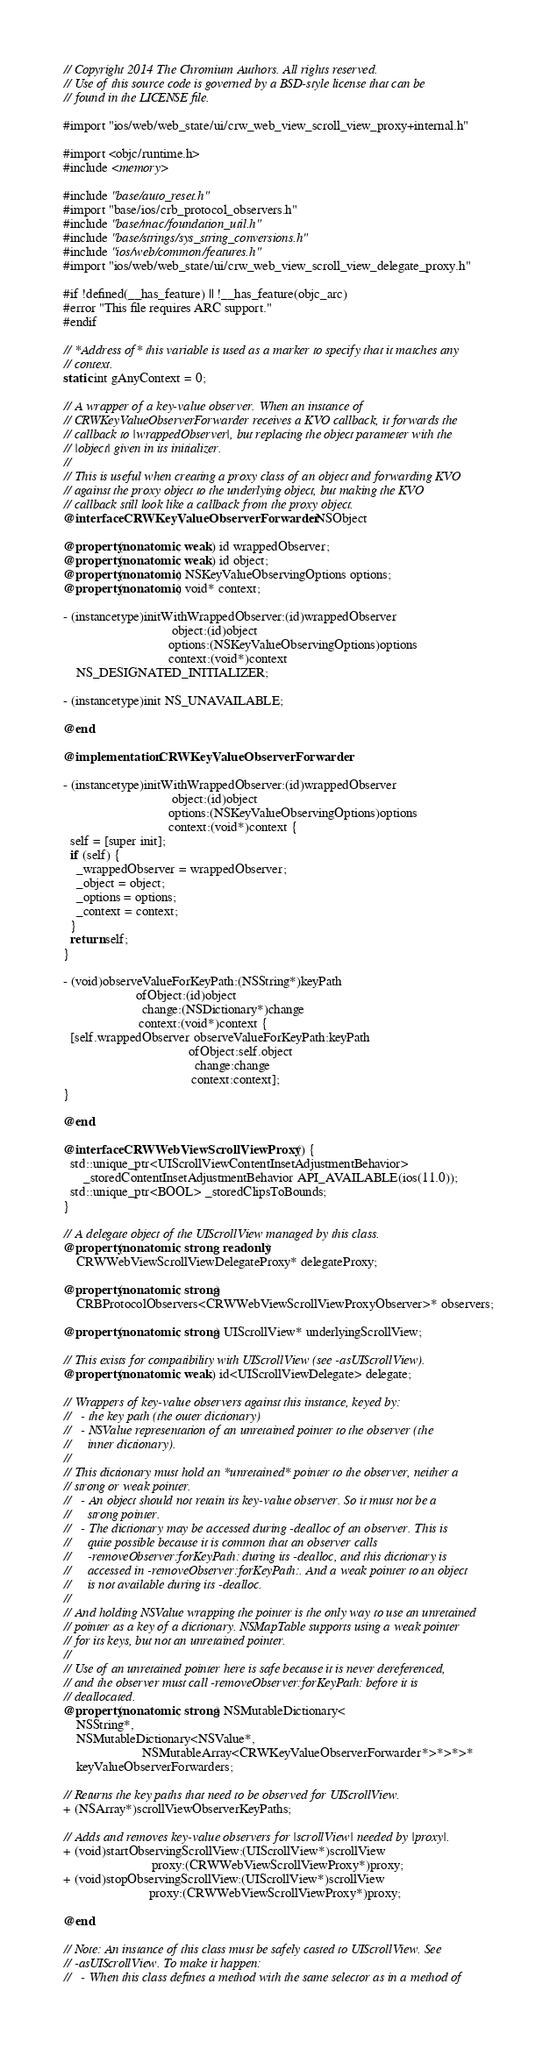<code> <loc_0><loc_0><loc_500><loc_500><_ObjectiveC_>// Copyright 2014 The Chromium Authors. All rights reserved.
// Use of this source code is governed by a BSD-style license that can be
// found in the LICENSE file.

#import "ios/web/web_state/ui/crw_web_view_scroll_view_proxy+internal.h"

#import <objc/runtime.h>
#include <memory>

#include "base/auto_reset.h"
#import "base/ios/crb_protocol_observers.h"
#include "base/mac/foundation_util.h"
#include "base/strings/sys_string_conversions.h"
#include "ios/web/common/features.h"
#import "ios/web/web_state/ui/crw_web_view_scroll_view_delegate_proxy.h"

#if !defined(__has_feature) || !__has_feature(objc_arc)
#error "This file requires ARC support."
#endif

// *Address of* this variable is used as a marker to specify that it matches any
// context.
static int gAnyContext = 0;

// A wrapper of a key-value observer. When an instance of
// CRWKeyValueObserverForwarder receives a KVO callback, it forwards the
// callback to |wrappedObserver|, but replacing the object parameter with the
// |object| given in its initializer.
//
// This is useful when creating a proxy class of an object and forwarding KVO
// against the proxy object to the underlying object, but making the KVO
// callback still look like a callback from the proxy object.
@interface CRWKeyValueObserverForwarder : NSObject

@property(nonatomic, weak) id wrappedObserver;
@property(nonatomic, weak) id object;
@property(nonatomic) NSKeyValueObservingOptions options;
@property(nonatomic) void* context;

- (instancetype)initWithWrappedObserver:(id)wrappedObserver
                                 object:(id)object
                                options:(NSKeyValueObservingOptions)options
                                context:(void*)context
    NS_DESIGNATED_INITIALIZER;

- (instancetype)init NS_UNAVAILABLE;

@end

@implementation CRWKeyValueObserverForwarder

- (instancetype)initWithWrappedObserver:(id)wrappedObserver
                                 object:(id)object
                                options:(NSKeyValueObservingOptions)options
                                context:(void*)context {
  self = [super init];
  if (self) {
    _wrappedObserver = wrappedObserver;
    _object = object;
    _options = options;
    _context = context;
  }
  return self;
}

- (void)observeValueForKeyPath:(NSString*)keyPath
                      ofObject:(id)object
                        change:(NSDictionary*)change
                       context:(void*)context {
  [self.wrappedObserver observeValueForKeyPath:keyPath
                                      ofObject:self.object
                                        change:change
                                       context:context];
}

@end

@interface CRWWebViewScrollViewProxy () {
  std::unique_ptr<UIScrollViewContentInsetAdjustmentBehavior>
      _storedContentInsetAdjustmentBehavior API_AVAILABLE(ios(11.0));
  std::unique_ptr<BOOL> _storedClipsToBounds;
}

// A delegate object of the UIScrollView managed by this class.
@property(nonatomic, strong, readonly)
    CRWWebViewScrollViewDelegateProxy* delegateProxy;

@property(nonatomic, strong)
    CRBProtocolObservers<CRWWebViewScrollViewProxyObserver>* observers;

@property(nonatomic, strong) UIScrollView* underlyingScrollView;

// This exists for compatibility with UIScrollView (see -asUIScrollView).
@property(nonatomic, weak) id<UIScrollViewDelegate> delegate;

// Wrappers of key-value observers against this instance, keyed by:
//   - the key path (the outer dictionary)
//   - NSValue representation of an unretained pointer to the observer (the
//     inner dictionary).
//
// This dictionary must hold an *unretained* pointer to the observer, neither a
// strong or weak pointer.
//   - An object should not retain its key-value observer. So it must not be a
//     strong pointer.
//   - The dictionary may be accessed during -dealloc of an observer. This is
//     quite possible because it is common that an observer calls
//     -removeObserver:forKeyPath: during its -dealloc, and this dictionary is
//     accessed in -removeObserver:forKeyPath:. And a weak pointer to an object
//     is not available during its -dealloc.
//
// And holding NSValue wrapping the pointer is the only way to use an unretained
// pointer as a key of a dictionary. NSMapTable supports using a weak pointer
// for its keys, but not an unretained pointer.
//
// Use of an unretained pointer here is safe because it is never dereferenced,
// and the observer must call -removeObserver:forKeyPath: before it is
// deallocated.
@property(nonatomic, strong) NSMutableDictionary<
    NSString*,
    NSMutableDictionary<NSValue*,
                        NSMutableArray<CRWKeyValueObserverForwarder*>*>*>*
    keyValueObserverForwarders;

// Returns the key paths that need to be observed for UIScrollView.
+ (NSArray*)scrollViewObserverKeyPaths;

// Adds and removes key-value observers for |scrollView| needed by |proxy|.
+ (void)startObservingScrollView:(UIScrollView*)scrollView
                           proxy:(CRWWebViewScrollViewProxy*)proxy;
+ (void)stopObservingScrollView:(UIScrollView*)scrollView
                          proxy:(CRWWebViewScrollViewProxy*)proxy;

@end

// Note: An instance of this class must be safely casted to UIScrollView. See
// -asUIScrollView. To make it happen:
//   - When this class defines a method with the same selector as in a method of</code> 